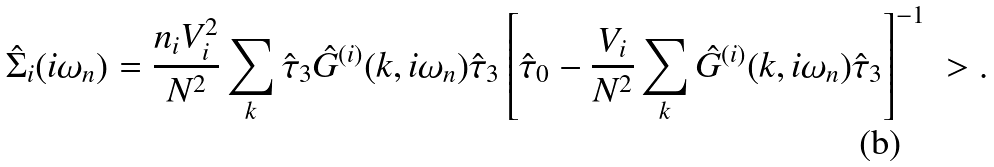<formula> <loc_0><loc_0><loc_500><loc_500>\hat { \Sigma } _ { i } ( i \omega _ { n } ) = \frac { n _ { i } V _ { i } ^ { 2 } } { N ^ { 2 } } \sum _ { k } \hat { \tau } _ { 3 } \hat { G } ^ { ( i ) } ( { k } , i \omega _ { n } ) \hat { \tau } _ { 3 } \left [ \hat { \tau } _ { 0 } - \frac { V _ { i } } { N ^ { 2 } } \sum _ { k } \hat { G } ^ { ( i ) } ( { k } , i \omega _ { n } ) \hat { \tau } _ { 3 } \right ] ^ { - 1 } \ > .</formula> 